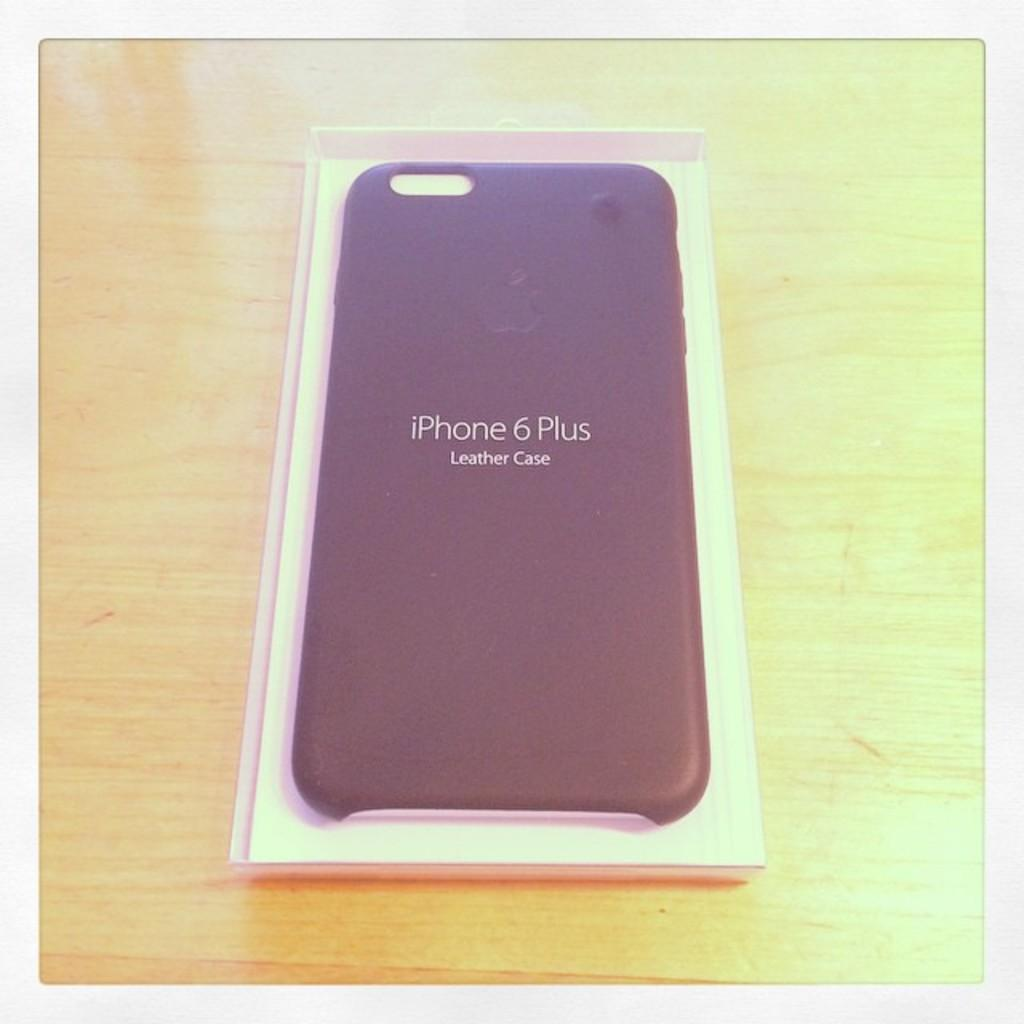Provide a one-sentence caption for the provided image. An Iphone 6 Plus leather case rests on a wooden table. 